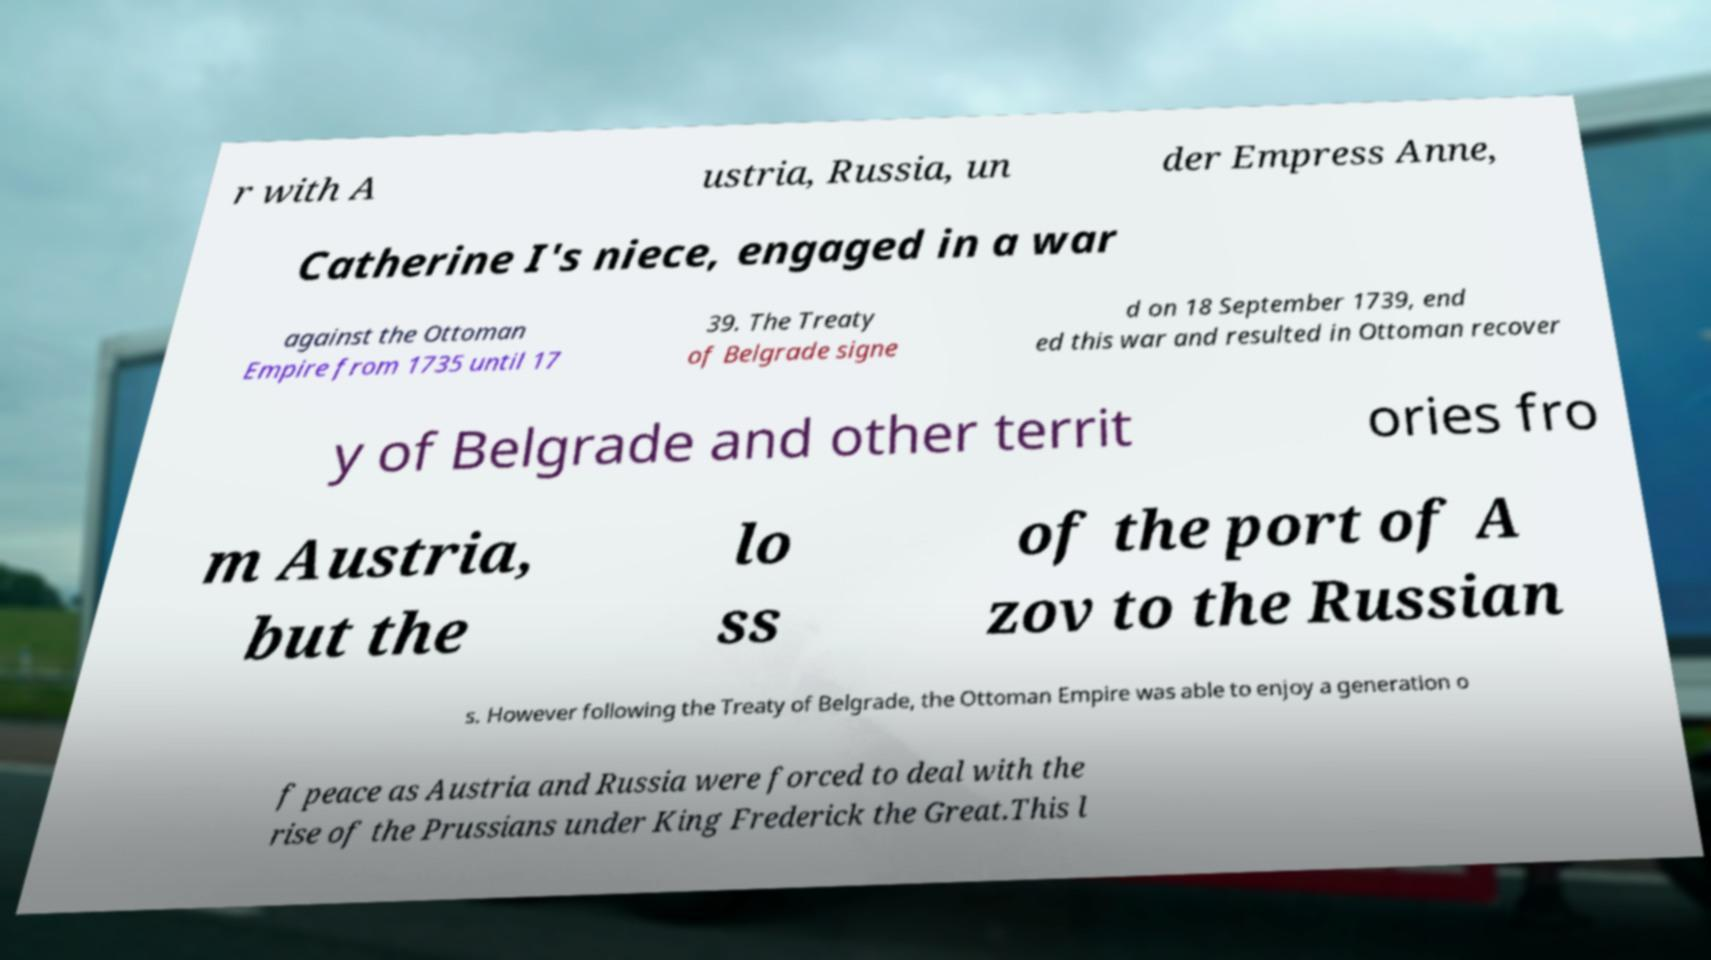Please read and relay the text visible in this image. What does it say? r with A ustria, Russia, un der Empress Anne, Catherine I's niece, engaged in a war against the Ottoman Empire from 1735 until 17 39. The Treaty of Belgrade signe d on 18 September 1739, end ed this war and resulted in Ottoman recover y of Belgrade and other territ ories fro m Austria, but the lo ss of the port of A zov to the Russian s. However following the Treaty of Belgrade, the Ottoman Empire was able to enjoy a generation o f peace as Austria and Russia were forced to deal with the rise of the Prussians under King Frederick the Great.This l 